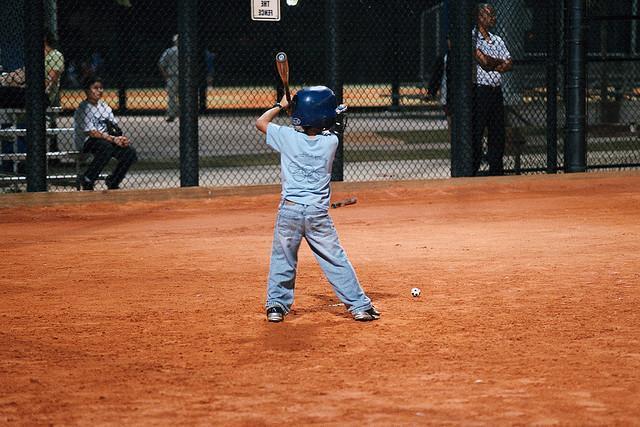What part of his uniform is he least likely to wear if he plays when he's older?
Choose the correct response and explain in the format: 'Answer: answer
Rationale: rationale.'
Options: Socks, sneakers, jeans, watch. Answer: jeans.
Rationale: He will have to wear the uniforms older players wear. 